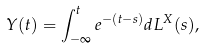Convert formula to latex. <formula><loc_0><loc_0><loc_500><loc_500>Y ( t ) = \int _ { - \infty } ^ { t } e ^ { - ( t - s ) } d L ^ { X } ( s ) ,</formula> 